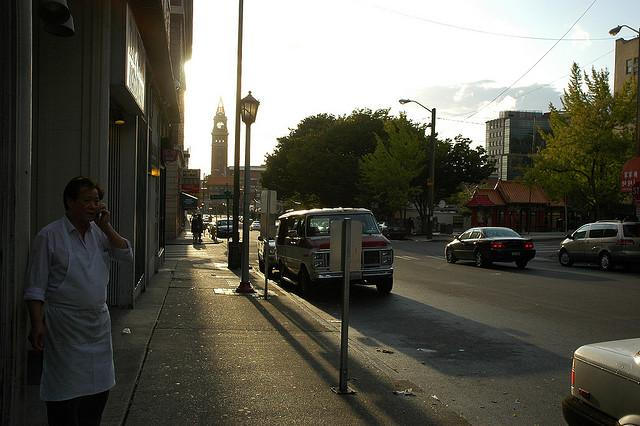What is the man in white apron holding to his ear? phone 